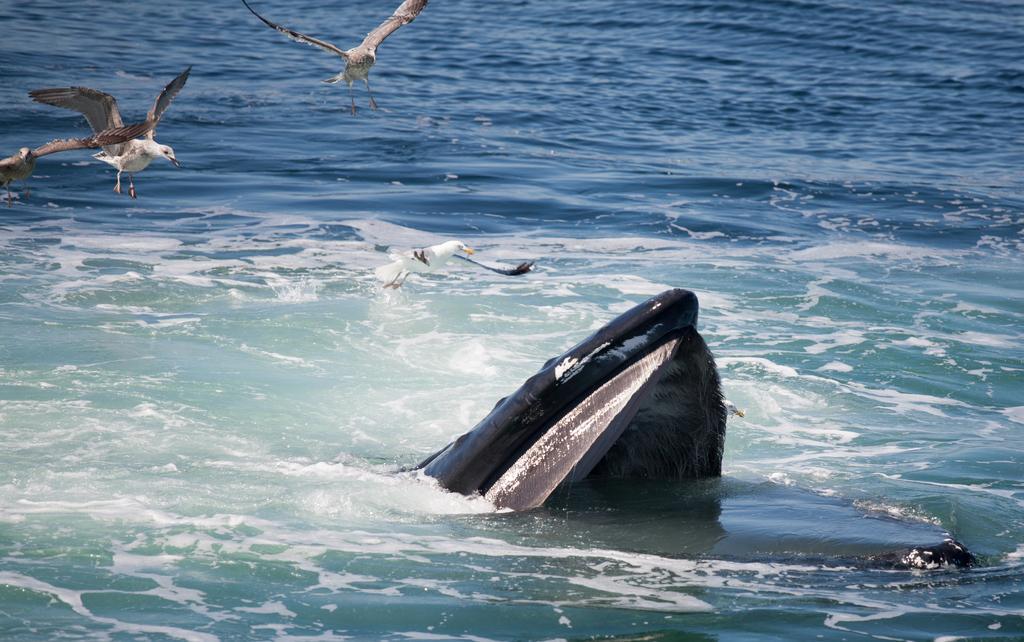How would you summarize this image in a sentence or two? In this image I can see at the bottom there is water. In the middle it looks like a fish, on the left side we can see few birds. 